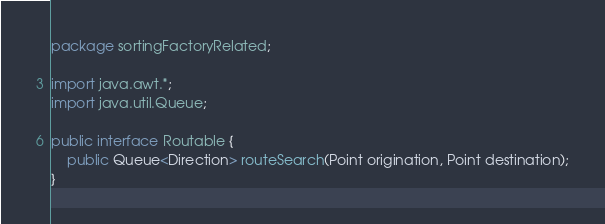Convert code to text. <code><loc_0><loc_0><loc_500><loc_500><_Java_>package sortingFactoryRelated;

import java.awt.*;
import java.util.Queue;

public interface Routable {
    public Queue<Direction> routeSearch(Point origination, Point destination);
}
</code> 